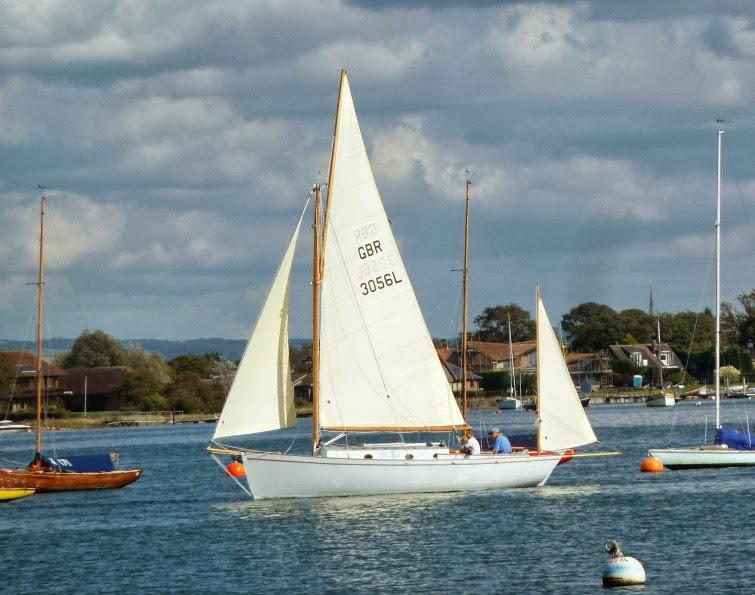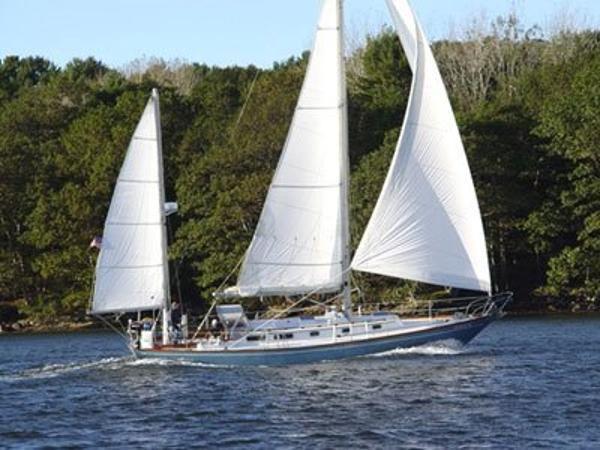The first image is the image on the left, the second image is the image on the right. Assess this claim about the two images: "At least one boat has three sails up.". Correct or not? Answer yes or no. Yes. The first image is the image on the left, the second image is the image on the right. Given the left and right images, does the statement "At least one of the images has a sky with nimbus clouds." hold true? Answer yes or no. Yes. 